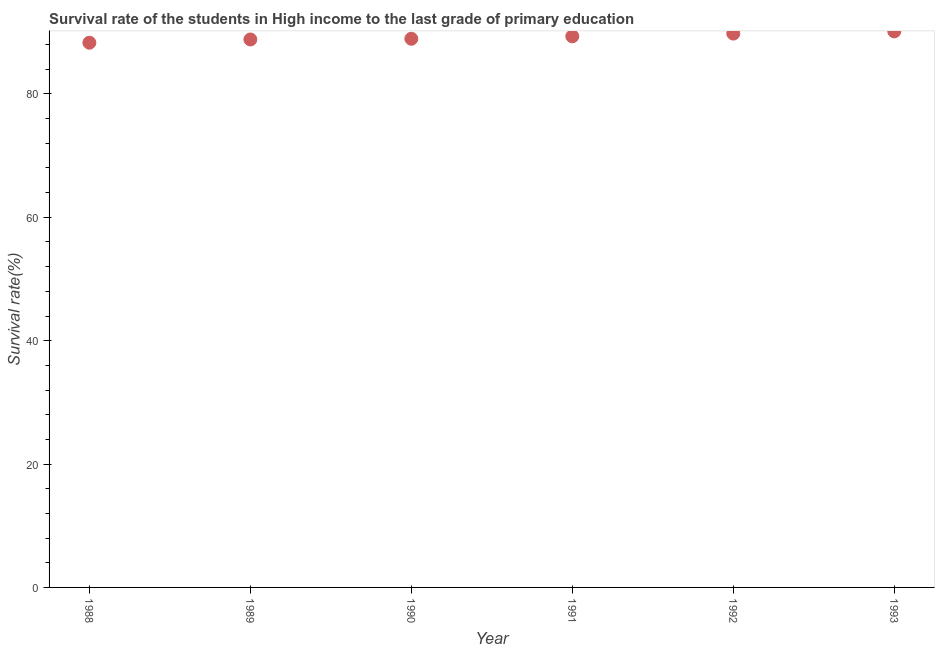What is the survival rate in primary education in 1990?
Keep it short and to the point. 88.95. Across all years, what is the maximum survival rate in primary education?
Keep it short and to the point. 90.14. Across all years, what is the minimum survival rate in primary education?
Provide a short and direct response. 88.31. What is the sum of the survival rate in primary education?
Give a very brief answer. 535.35. What is the difference between the survival rate in primary education in 1989 and 1991?
Your answer should be compact. -0.51. What is the average survival rate in primary education per year?
Offer a very short reply. 89.23. What is the median survival rate in primary education?
Provide a short and direct response. 89.14. In how many years, is the survival rate in primary education greater than 24 %?
Your response must be concise. 6. What is the ratio of the survival rate in primary education in 1988 to that in 1990?
Give a very brief answer. 0.99. Is the survival rate in primary education in 1990 less than that in 1992?
Give a very brief answer. Yes. What is the difference between the highest and the second highest survival rate in primary education?
Your answer should be very brief. 0.36. What is the difference between the highest and the lowest survival rate in primary education?
Offer a very short reply. 1.83. Does the survival rate in primary education monotonically increase over the years?
Your response must be concise. Yes. Does the graph contain any zero values?
Make the answer very short. No. What is the title of the graph?
Your answer should be compact. Survival rate of the students in High income to the last grade of primary education. What is the label or title of the X-axis?
Your response must be concise. Year. What is the label or title of the Y-axis?
Keep it short and to the point. Survival rate(%). What is the Survival rate(%) in 1988?
Keep it short and to the point. 88.31. What is the Survival rate(%) in 1989?
Ensure brevity in your answer.  88.83. What is the Survival rate(%) in 1990?
Your response must be concise. 88.95. What is the Survival rate(%) in 1991?
Give a very brief answer. 89.34. What is the Survival rate(%) in 1992?
Provide a succinct answer. 89.79. What is the Survival rate(%) in 1993?
Give a very brief answer. 90.14. What is the difference between the Survival rate(%) in 1988 and 1989?
Provide a short and direct response. -0.53. What is the difference between the Survival rate(%) in 1988 and 1990?
Offer a terse response. -0.64. What is the difference between the Survival rate(%) in 1988 and 1991?
Provide a short and direct response. -1.03. What is the difference between the Survival rate(%) in 1988 and 1992?
Provide a succinct answer. -1.48. What is the difference between the Survival rate(%) in 1988 and 1993?
Your answer should be very brief. -1.83. What is the difference between the Survival rate(%) in 1989 and 1990?
Keep it short and to the point. -0.11. What is the difference between the Survival rate(%) in 1989 and 1991?
Your answer should be very brief. -0.51. What is the difference between the Survival rate(%) in 1989 and 1992?
Make the answer very short. -0.95. What is the difference between the Survival rate(%) in 1989 and 1993?
Offer a very short reply. -1.31. What is the difference between the Survival rate(%) in 1990 and 1991?
Offer a terse response. -0.39. What is the difference between the Survival rate(%) in 1990 and 1992?
Your answer should be very brief. -0.84. What is the difference between the Survival rate(%) in 1990 and 1993?
Provide a succinct answer. -1.19. What is the difference between the Survival rate(%) in 1991 and 1992?
Your answer should be very brief. -0.44. What is the difference between the Survival rate(%) in 1991 and 1993?
Provide a succinct answer. -0.8. What is the difference between the Survival rate(%) in 1992 and 1993?
Offer a very short reply. -0.36. What is the ratio of the Survival rate(%) in 1988 to that in 1989?
Your response must be concise. 0.99. What is the ratio of the Survival rate(%) in 1988 to that in 1991?
Keep it short and to the point. 0.99. What is the ratio of the Survival rate(%) in 1988 to that in 1992?
Offer a terse response. 0.98. What is the ratio of the Survival rate(%) in 1988 to that in 1993?
Give a very brief answer. 0.98. What is the ratio of the Survival rate(%) in 1989 to that in 1993?
Keep it short and to the point. 0.98. What is the ratio of the Survival rate(%) in 1990 to that in 1992?
Your response must be concise. 0.99. What is the ratio of the Survival rate(%) in 1991 to that in 1992?
Provide a succinct answer. 0.99. What is the ratio of the Survival rate(%) in 1991 to that in 1993?
Ensure brevity in your answer.  0.99. What is the ratio of the Survival rate(%) in 1992 to that in 1993?
Provide a short and direct response. 1. 